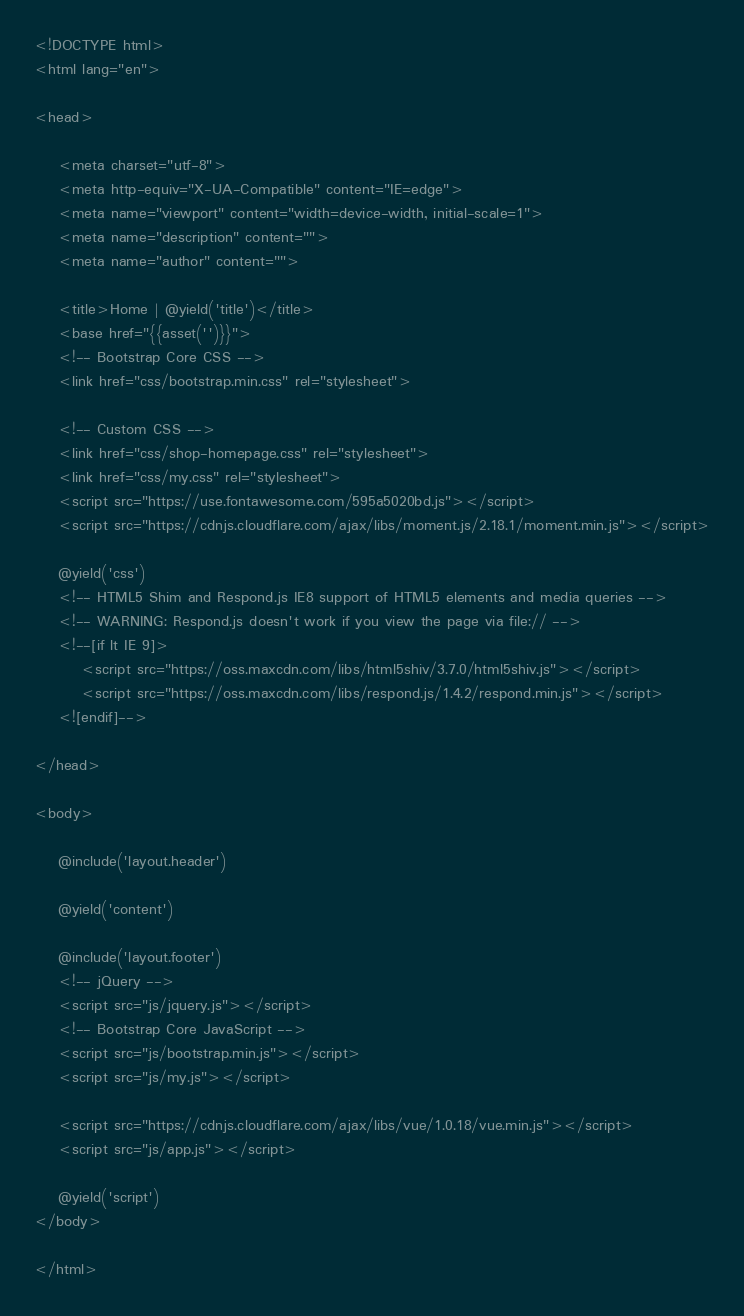<code> <loc_0><loc_0><loc_500><loc_500><_PHP_><!DOCTYPE html>
<html lang="en">

<head>

    <meta charset="utf-8">
    <meta http-equiv="X-UA-Compatible" content="IE=edge">
    <meta name="viewport" content="width=device-width, initial-scale=1">
    <meta name="description" content="">
    <meta name="author" content="">

    <title>Home | @yield('title')</title>
    <base href="{{asset('')}}">
    <!-- Bootstrap Core CSS -->
    <link href="css/bootstrap.min.css" rel="stylesheet">

    <!-- Custom CSS -->
    <link href="css/shop-homepage.css" rel="stylesheet">
    <link href="css/my.css" rel="stylesheet">
    <script src="https://use.fontawesome.com/595a5020bd.js"></script>
    <script src="https://cdnjs.cloudflare.com/ajax/libs/moment.js/2.18.1/moment.min.js"></script>
    
    @yield('css')
    <!-- HTML5 Shim and Respond.js IE8 support of HTML5 elements and media queries -->
    <!-- WARNING: Respond.js doesn't work if you view the page via file:// -->
    <!--[if lt IE 9]>
        <script src="https://oss.maxcdn.com/libs/html5shiv/3.7.0/html5shiv.js"></script>
        <script src="https://oss.maxcdn.com/libs/respond.js/1.4.2/respond.min.js"></script>
    <![endif]-->

</head>

<body>

    @include('layout.header')

    @yield('content')

    @include('layout.footer')
    <!-- jQuery -->
    <script src="js/jquery.js"></script>
    <!-- Bootstrap Core JavaScript -->
    <script src="js/bootstrap.min.js"></script>
    <script src="js/my.js"></script>
    
    <script src="https://cdnjs.cloudflare.com/ajax/libs/vue/1.0.18/vue.min.js"></script>
    <script src="js/app.js"></script>

    @yield('script')
</body>

</html></code> 